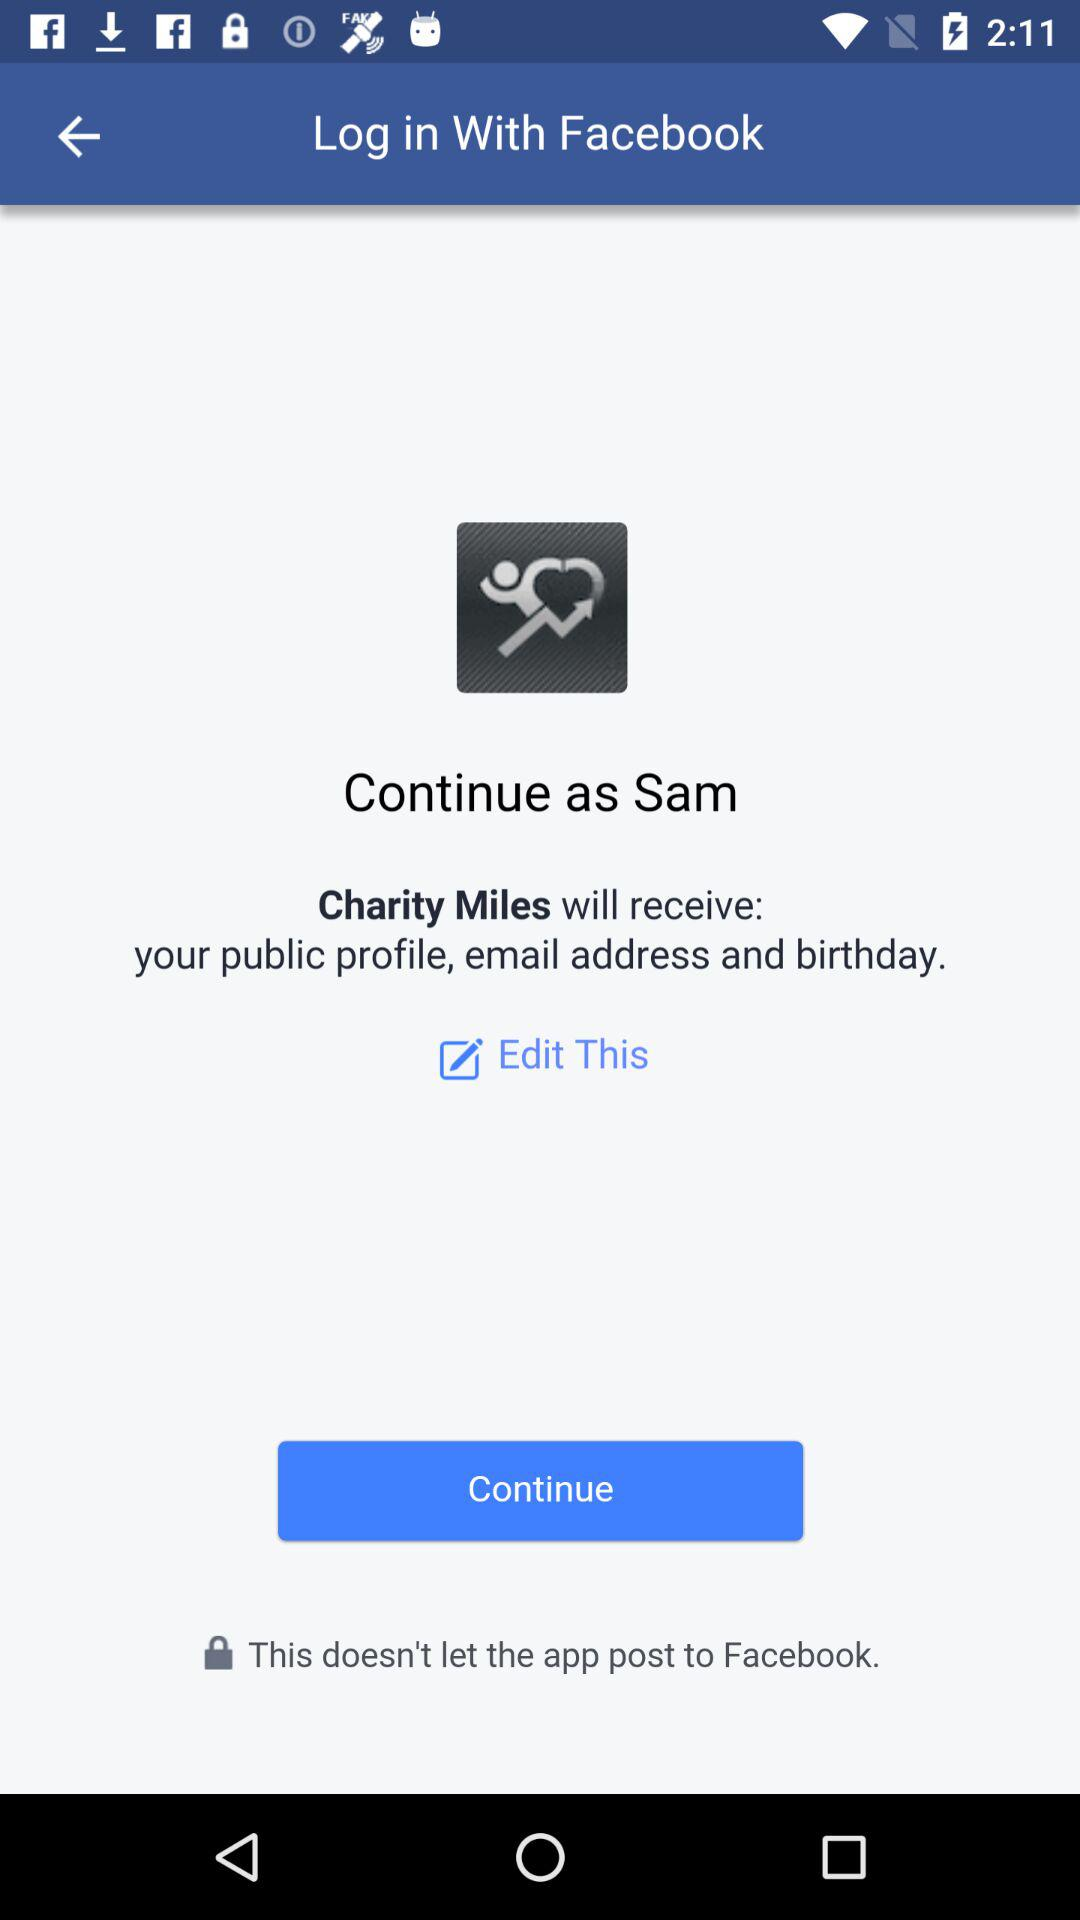What application is asking for permission? The application "Charity Miles" is asking for permission. 